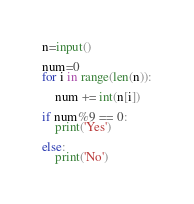<code> <loc_0><loc_0><loc_500><loc_500><_Python_>n=input()

num=0
for i in range(len(n)):

    num += int(n[i])

if num%9 == 0:
    print('Yes')

else:
    print('No')
</code> 